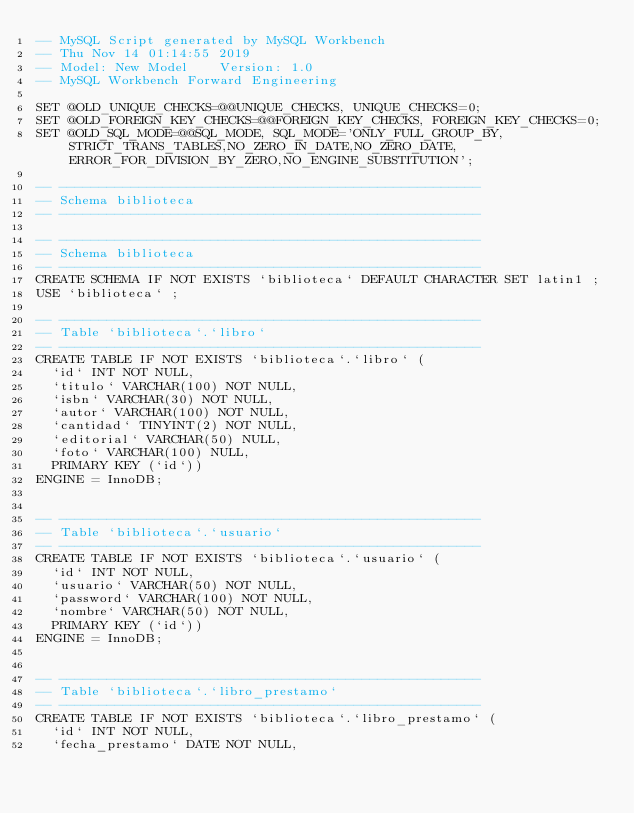<code> <loc_0><loc_0><loc_500><loc_500><_SQL_>-- MySQL Script generated by MySQL Workbench
-- Thu Nov 14 01:14:55 2019
-- Model: New Model    Version: 1.0
-- MySQL Workbench Forward Engineering

SET @OLD_UNIQUE_CHECKS=@@UNIQUE_CHECKS, UNIQUE_CHECKS=0;
SET @OLD_FOREIGN_KEY_CHECKS=@@FOREIGN_KEY_CHECKS, FOREIGN_KEY_CHECKS=0;
SET @OLD_SQL_MODE=@@SQL_MODE, SQL_MODE='ONLY_FULL_GROUP_BY,STRICT_TRANS_TABLES,NO_ZERO_IN_DATE,NO_ZERO_DATE,ERROR_FOR_DIVISION_BY_ZERO,NO_ENGINE_SUBSTITUTION';

-- -----------------------------------------------------
-- Schema biblioteca
-- -----------------------------------------------------

-- -----------------------------------------------------
-- Schema biblioteca
-- -----------------------------------------------------
CREATE SCHEMA IF NOT EXISTS `biblioteca` DEFAULT CHARACTER SET latin1 ;
USE `biblioteca` ;

-- -----------------------------------------------------
-- Table `biblioteca`.`libro`
-- -----------------------------------------------------
CREATE TABLE IF NOT EXISTS `biblioteca`.`libro` (
  `id` INT NOT NULL,
  `titulo` VARCHAR(100) NOT NULL,
  `isbn` VARCHAR(30) NOT NULL,
  `autor` VARCHAR(100) NOT NULL,
  `cantidad` TINYINT(2) NOT NULL,
  `editorial` VARCHAR(50) NULL,
  `foto` VARCHAR(100) NULL,
  PRIMARY KEY (`id`))
ENGINE = InnoDB;


-- -----------------------------------------------------
-- Table `biblioteca`.`usuario`
-- -----------------------------------------------------
CREATE TABLE IF NOT EXISTS `biblioteca`.`usuario` (
  `id` INT NOT NULL,
  `usuario` VARCHAR(50) NOT NULL,
  `password` VARCHAR(100) NOT NULL,
  `nombre` VARCHAR(50) NOT NULL,
  PRIMARY KEY (`id`))
ENGINE = InnoDB;


-- -----------------------------------------------------
-- Table `biblioteca`.`libro_prestamo`
-- -----------------------------------------------------
CREATE TABLE IF NOT EXISTS `biblioteca`.`libro_prestamo` (
  `id` INT NOT NULL,
  `fecha_prestamo` DATE NOT NULL,</code> 